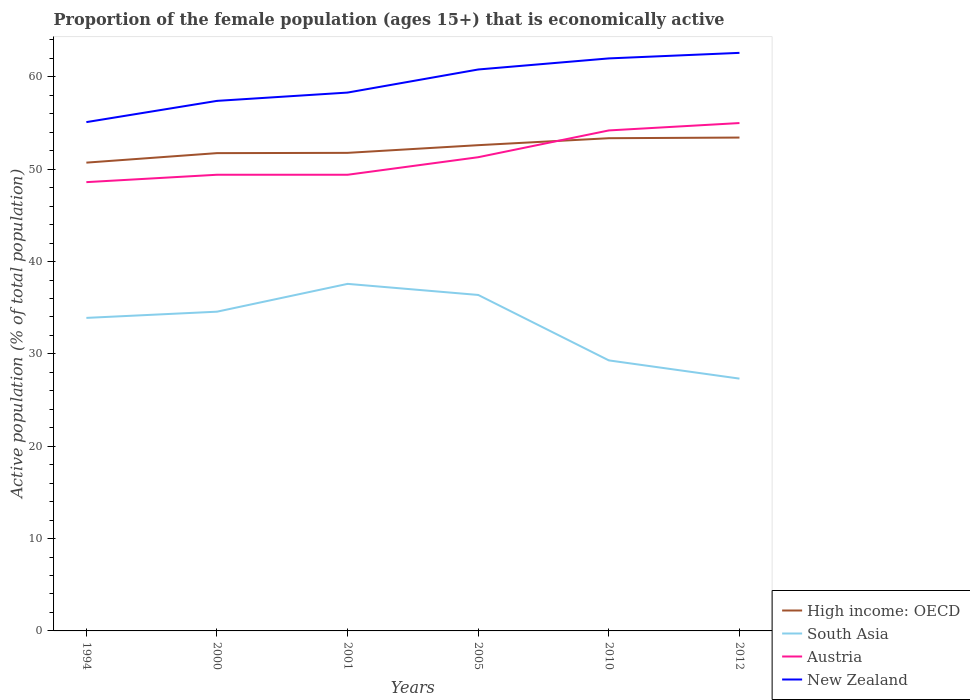Is the number of lines equal to the number of legend labels?
Offer a very short reply. Yes. Across all years, what is the maximum proportion of the female population that is economically active in South Asia?
Your answer should be very brief. 27.32. In which year was the proportion of the female population that is economically active in Austria maximum?
Keep it short and to the point. 1994. What is the total proportion of the female population that is economically active in New Zealand in the graph?
Offer a very short reply. -2.5. What is the difference between the highest and the second highest proportion of the female population that is economically active in South Asia?
Offer a terse response. 10.26. What is the difference between the highest and the lowest proportion of the female population that is economically active in Austria?
Provide a succinct answer. 2. Is the proportion of the female population that is economically active in High income: OECD strictly greater than the proportion of the female population that is economically active in South Asia over the years?
Offer a very short reply. No. How many lines are there?
Make the answer very short. 4. How many years are there in the graph?
Keep it short and to the point. 6. Are the values on the major ticks of Y-axis written in scientific E-notation?
Make the answer very short. No. Does the graph contain grids?
Offer a very short reply. No. How are the legend labels stacked?
Offer a very short reply. Vertical. What is the title of the graph?
Your response must be concise. Proportion of the female population (ages 15+) that is economically active. Does "Ukraine" appear as one of the legend labels in the graph?
Give a very brief answer. No. What is the label or title of the Y-axis?
Give a very brief answer. Active population (% of total population). What is the Active population (% of total population) of High income: OECD in 1994?
Give a very brief answer. 50.71. What is the Active population (% of total population) of South Asia in 1994?
Your response must be concise. 33.9. What is the Active population (% of total population) in Austria in 1994?
Make the answer very short. 48.6. What is the Active population (% of total population) of New Zealand in 1994?
Make the answer very short. 55.1. What is the Active population (% of total population) in High income: OECD in 2000?
Provide a succinct answer. 51.74. What is the Active population (% of total population) of South Asia in 2000?
Ensure brevity in your answer.  34.57. What is the Active population (% of total population) in Austria in 2000?
Give a very brief answer. 49.4. What is the Active population (% of total population) of New Zealand in 2000?
Give a very brief answer. 57.4. What is the Active population (% of total population) in High income: OECD in 2001?
Ensure brevity in your answer.  51.77. What is the Active population (% of total population) of South Asia in 2001?
Your answer should be compact. 37.58. What is the Active population (% of total population) of Austria in 2001?
Your response must be concise. 49.4. What is the Active population (% of total population) of New Zealand in 2001?
Your answer should be very brief. 58.3. What is the Active population (% of total population) in High income: OECD in 2005?
Your response must be concise. 52.6. What is the Active population (% of total population) in South Asia in 2005?
Provide a short and direct response. 36.38. What is the Active population (% of total population) of Austria in 2005?
Offer a very short reply. 51.3. What is the Active population (% of total population) in New Zealand in 2005?
Provide a short and direct response. 60.8. What is the Active population (% of total population) of High income: OECD in 2010?
Keep it short and to the point. 53.36. What is the Active population (% of total population) in South Asia in 2010?
Ensure brevity in your answer.  29.3. What is the Active population (% of total population) of Austria in 2010?
Your response must be concise. 54.2. What is the Active population (% of total population) of New Zealand in 2010?
Ensure brevity in your answer.  62. What is the Active population (% of total population) in High income: OECD in 2012?
Give a very brief answer. 53.43. What is the Active population (% of total population) in South Asia in 2012?
Make the answer very short. 27.32. What is the Active population (% of total population) of Austria in 2012?
Offer a very short reply. 55. What is the Active population (% of total population) in New Zealand in 2012?
Your answer should be compact. 62.6. Across all years, what is the maximum Active population (% of total population) of High income: OECD?
Give a very brief answer. 53.43. Across all years, what is the maximum Active population (% of total population) in South Asia?
Offer a terse response. 37.58. Across all years, what is the maximum Active population (% of total population) of New Zealand?
Offer a terse response. 62.6. Across all years, what is the minimum Active population (% of total population) of High income: OECD?
Provide a succinct answer. 50.71. Across all years, what is the minimum Active population (% of total population) in South Asia?
Offer a very short reply. 27.32. Across all years, what is the minimum Active population (% of total population) of Austria?
Offer a terse response. 48.6. Across all years, what is the minimum Active population (% of total population) in New Zealand?
Give a very brief answer. 55.1. What is the total Active population (% of total population) in High income: OECD in the graph?
Offer a terse response. 313.62. What is the total Active population (% of total population) of South Asia in the graph?
Give a very brief answer. 199.06. What is the total Active population (% of total population) of Austria in the graph?
Your response must be concise. 307.9. What is the total Active population (% of total population) in New Zealand in the graph?
Give a very brief answer. 356.2. What is the difference between the Active population (% of total population) of High income: OECD in 1994 and that in 2000?
Make the answer very short. -1.03. What is the difference between the Active population (% of total population) in South Asia in 1994 and that in 2000?
Give a very brief answer. -0.67. What is the difference between the Active population (% of total population) of High income: OECD in 1994 and that in 2001?
Make the answer very short. -1.06. What is the difference between the Active population (% of total population) of South Asia in 1994 and that in 2001?
Your response must be concise. -3.68. What is the difference between the Active population (% of total population) of High income: OECD in 1994 and that in 2005?
Provide a short and direct response. -1.89. What is the difference between the Active population (% of total population) in South Asia in 1994 and that in 2005?
Provide a succinct answer. -2.48. What is the difference between the Active population (% of total population) of Austria in 1994 and that in 2005?
Make the answer very short. -2.7. What is the difference between the Active population (% of total population) in New Zealand in 1994 and that in 2005?
Make the answer very short. -5.7. What is the difference between the Active population (% of total population) of High income: OECD in 1994 and that in 2010?
Provide a succinct answer. -2.65. What is the difference between the Active population (% of total population) of South Asia in 1994 and that in 2010?
Provide a short and direct response. 4.6. What is the difference between the Active population (% of total population) in High income: OECD in 1994 and that in 2012?
Offer a very short reply. -2.71. What is the difference between the Active population (% of total population) of South Asia in 1994 and that in 2012?
Offer a very short reply. 6.58. What is the difference between the Active population (% of total population) in New Zealand in 1994 and that in 2012?
Make the answer very short. -7.5. What is the difference between the Active population (% of total population) in High income: OECD in 2000 and that in 2001?
Provide a succinct answer. -0.03. What is the difference between the Active population (% of total population) in South Asia in 2000 and that in 2001?
Provide a succinct answer. -3.01. What is the difference between the Active population (% of total population) in Austria in 2000 and that in 2001?
Your response must be concise. 0. What is the difference between the Active population (% of total population) in High income: OECD in 2000 and that in 2005?
Offer a terse response. -0.86. What is the difference between the Active population (% of total population) in South Asia in 2000 and that in 2005?
Your response must be concise. -1.81. What is the difference between the Active population (% of total population) of New Zealand in 2000 and that in 2005?
Your response must be concise. -3.4. What is the difference between the Active population (% of total population) in High income: OECD in 2000 and that in 2010?
Ensure brevity in your answer.  -1.62. What is the difference between the Active population (% of total population) in South Asia in 2000 and that in 2010?
Ensure brevity in your answer.  5.27. What is the difference between the Active population (% of total population) of Austria in 2000 and that in 2010?
Provide a short and direct response. -4.8. What is the difference between the Active population (% of total population) in High income: OECD in 2000 and that in 2012?
Your response must be concise. -1.68. What is the difference between the Active population (% of total population) in South Asia in 2000 and that in 2012?
Make the answer very short. 7.25. What is the difference between the Active population (% of total population) of New Zealand in 2000 and that in 2012?
Make the answer very short. -5.2. What is the difference between the Active population (% of total population) in High income: OECD in 2001 and that in 2005?
Your answer should be compact. -0.83. What is the difference between the Active population (% of total population) in South Asia in 2001 and that in 2005?
Provide a succinct answer. 1.2. What is the difference between the Active population (% of total population) in Austria in 2001 and that in 2005?
Keep it short and to the point. -1.9. What is the difference between the Active population (% of total population) in New Zealand in 2001 and that in 2005?
Make the answer very short. -2.5. What is the difference between the Active population (% of total population) in High income: OECD in 2001 and that in 2010?
Your answer should be compact. -1.59. What is the difference between the Active population (% of total population) of South Asia in 2001 and that in 2010?
Your response must be concise. 8.29. What is the difference between the Active population (% of total population) of Austria in 2001 and that in 2010?
Your response must be concise. -4.8. What is the difference between the Active population (% of total population) in New Zealand in 2001 and that in 2010?
Offer a terse response. -3.7. What is the difference between the Active population (% of total population) of High income: OECD in 2001 and that in 2012?
Offer a terse response. -1.66. What is the difference between the Active population (% of total population) in South Asia in 2001 and that in 2012?
Provide a short and direct response. 10.26. What is the difference between the Active population (% of total population) in Austria in 2001 and that in 2012?
Give a very brief answer. -5.6. What is the difference between the Active population (% of total population) in High income: OECD in 2005 and that in 2010?
Ensure brevity in your answer.  -0.76. What is the difference between the Active population (% of total population) in South Asia in 2005 and that in 2010?
Offer a very short reply. 7.09. What is the difference between the Active population (% of total population) of New Zealand in 2005 and that in 2010?
Ensure brevity in your answer.  -1.2. What is the difference between the Active population (% of total population) in High income: OECD in 2005 and that in 2012?
Make the answer very short. -0.82. What is the difference between the Active population (% of total population) of South Asia in 2005 and that in 2012?
Offer a very short reply. 9.06. What is the difference between the Active population (% of total population) in Austria in 2005 and that in 2012?
Give a very brief answer. -3.7. What is the difference between the Active population (% of total population) of High income: OECD in 2010 and that in 2012?
Provide a succinct answer. -0.07. What is the difference between the Active population (% of total population) in South Asia in 2010 and that in 2012?
Offer a very short reply. 1.97. What is the difference between the Active population (% of total population) of High income: OECD in 1994 and the Active population (% of total population) of South Asia in 2000?
Your answer should be compact. 16.14. What is the difference between the Active population (% of total population) of High income: OECD in 1994 and the Active population (% of total population) of Austria in 2000?
Ensure brevity in your answer.  1.31. What is the difference between the Active population (% of total population) of High income: OECD in 1994 and the Active population (% of total population) of New Zealand in 2000?
Make the answer very short. -6.69. What is the difference between the Active population (% of total population) of South Asia in 1994 and the Active population (% of total population) of Austria in 2000?
Offer a very short reply. -15.5. What is the difference between the Active population (% of total population) in South Asia in 1994 and the Active population (% of total population) in New Zealand in 2000?
Offer a very short reply. -23.5. What is the difference between the Active population (% of total population) in Austria in 1994 and the Active population (% of total population) in New Zealand in 2000?
Give a very brief answer. -8.8. What is the difference between the Active population (% of total population) of High income: OECD in 1994 and the Active population (% of total population) of South Asia in 2001?
Your answer should be compact. 13.13. What is the difference between the Active population (% of total population) in High income: OECD in 1994 and the Active population (% of total population) in Austria in 2001?
Provide a short and direct response. 1.31. What is the difference between the Active population (% of total population) of High income: OECD in 1994 and the Active population (% of total population) of New Zealand in 2001?
Make the answer very short. -7.59. What is the difference between the Active population (% of total population) in South Asia in 1994 and the Active population (% of total population) in Austria in 2001?
Offer a very short reply. -15.5. What is the difference between the Active population (% of total population) of South Asia in 1994 and the Active population (% of total population) of New Zealand in 2001?
Provide a short and direct response. -24.4. What is the difference between the Active population (% of total population) in Austria in 1994 and the Active population (% of total population) in New Zealand in 2001?
Your answer should be compact. -9.7. What is the difference between the Active population (% of total population) in High income: OECD in 1994 and the Active population (% of total population) in South Asia in 2005?
Provide a succinct answer. 14.33. What is the difference between the Active population (% of total population) of High income: OECD in 1994 and the Active population (% of total population) of Austria in 2005?
Keep it short and to the point. -0.59. What is the difference between the Active population (% of total population) in High income: OECD in 1994 and the Active population (% of total population) in New Zealand in 2005?
Give a very brief answer. -10.09. What is the difference between the Active population (% of total population) of South Asia in 1994 and the Active population (% of total population) of Austria in 2005?
Offer a very short reply. -17.4. What is the difference between the Active population (% of total population) of South Asia in 1994 and the Active population (% of total population) of New Zealand in 2005?
Provide a short and direct response. -26.9. What is the difference between the Active population (% of total population) in High income: OECD in 1994 and the Active population (% of total population) in South Asia in 2010?
Provide a succinct answer. 21.42. What is the difference between the Active population (% of total population) in High income: OECD in 1994 and the Active population (% of total population) in Austria in 2010?
Give a very brief answer. -3.49. What is the difference between the Active population (% of total population) in High income: OECD in 1994 and the Active population (% of total population) in New Zealand in 2010?
Ensure brevity in your answer.  -11.29. What is the difference between the Active population (% of total population) in South Asia in 1994 and the Active population (% of total population) in Austria in 2010?
Provide a succinct answer. -20.3. What is the difference between the Active population (% of total population) in South Asia in 1994 and the Active population (% of total population) in New Zealand in 2010?
Offer a terse response. -28.1. What is the difference between the Active population (% of total population) in High income: OECD in 1994 and the Active population (% of total population) in South Asia in 2012?
Give a very brief answer. 23.39. What is the difference between the Active population (% of total population) of High income: OECD in 1994 and the Active population (% of total population) of Austria in 2012?
Your response must be concise. -4.29. What is the difference between the Active population (% of total population) in High income: OECD in 1994 and the Active population (% of total population) in New Zealand in 2012?
Your response must be concise. -11.89. What is the difference between the Active population (% of total population) of South Asia in 1994 and the Active population (% of total population) of Austria in 2012?
Keep it short and to the point. -21.1. What is the difference between the Active population (% of total population) of South Asia in 1994 and the Active population (% of total population) of New Zealand in 2012?
Ensure brevity in your answer.  -28.7. What is the difference between the Active population (% of total population) in Austria in 1994 and the Active population (% of total population) in New Zealand in 2012?
Offer a very short reply. -14. What is the difference between the Active population (% of total population) in High income: OECD in 2000 and the Active population (% of total population) in South Asia in 2001?
Offer a very short reply. 14.16. What is the difference between the Active population (% of total population) of High income: OECD in 2000 and the Active population (% of total population) of Austria in 2001?
Your answer should be very brief. 2.34. What is the difference between the Active population (% of total population) of High income: OECD in 2000 and the Active population (% of total population) of New Zealand in 2001?
Offer a very short reply. -6.56. What is the difference between the Active population (% of total population) of South Asia in 2000 and the Active population (% of total population) of Austria in 2001?
Your response must be concise. -14.83. What is the difference between the Active population (% of total population) in South Asia in 2000 and the Active population (% of total population) in New Zealand in 2001?
Your response must be concise. -23.73. What is the difference between the Active population (% of total population) in Austria in 2000 and the Active population (% of total population) in New Zealand in 2001?
Make the answer very short. -8.9. What is the difference between the Active population (% of total population) in High income: OECD in 2000 and the Active population (% of total population) in South Asia in 2005?
Provide a short and direct response. 15.36. What is the difference between the Active population (% of total population) of High income: OECD in 2000 and the Active population (% of total population) of Austria in 2005?
Your response must be concise. 0.44. What is the difference between the Active population (% of total population) of High income: OECD in 2000 and the Active population (% of total population) of New Zealand in 2005?
Keep it short and to the point. -9.06. What is the difference between the Active population (% of total population) in South Asia in 2000 and the Active population (% of total population) in Austria in 2005?
Your answer should be very brief. -16.73. What is the difference between the Active population (% of total population) in South Asia in 2000 and the Active population (% of total population) in New Zealand in 2005?
Offer a terse response. -26.23. What is the difference between the Active population (% of total population) of Austria in 2000 and the Active population (% of total population) of New Zealand in 2005?
Ensure brevity in your answer.  -11.4. What is the difference between the Active population (% of total population) in High income: OECD in 2000 and the Active population (% of total population) in South Asia in 2010?
Your answer should be compact. 22.45. What is the difference between the Active population (% of total population) in High income: OECD in 2000 and the Active population (% of total population) in Austria in 2010?
Provide a succinct answer. -2.46. What is the difference between the Active population (% of total population) in High income: OECD in 2000 and the Active population (% of total population) in New Zealand in 2010?
Your response must be concise. -10.26. What is the difference between the Active population (% of total population) of South Asia in 2000 and the Active population (% of total population) of Austria in 2010?
Your answer should be compact. -19.63. What is the difference between the Active population (% of total population) in South Asia in 2000 and the Active population (% of total population) in New Zealand in 2010?
Offer a very short reply. -27.43. What is the difference between the Active population (% of total population) of High income: OECD in 2000 and the Active population (% of total population) of South Asia in 2012?
Provide a succinct answer. 24.42. What is the difference between the Active population (% of total population) in High income: OECD in 2000 and the Active population (% of total population) in Austria in 2012?
Ensure brevity in your answer.  -3.26. What is the difference between the Active population (% of total population) of High income: OECD in 2000 and the Active population (% of total population) of New Zealand in 2012?
Your response must be concise. -10.86. What is the difference between the Active population (% of total population) in South Asia in 2000 and the Active population (% of total population) in Austria in 2012?
Your response must be concise. -20.43. What is the difference between the Active population (% of total population) in South Asia in 2000 and the Active population (% of total population) in New Zealand in 2012?
Give a very brief answer. -28.03. What is the difference between the Active population (% of total population) in Austria in 2000 and the Active population (% of total population) in New Zealand in 2012?
Your answer should be compact. -13.2. What is the difference between the Active population (% of total population) in High income: OECD in 2001 and the Active population (% of total population) in South Asia in 2005?
Provide a short and direct response. 15.39. What is the difference between the Active population (% of total population) of High income: OECD in 2001 and the Active population (% of total population) of Austria in 2005?
Provide a succinct answer. 0.47. What is the difference between the Active population (% of total population) of High income: OECD in 2001 and the Active population (% of total population) of New Zealand in 2005?
Provide a short and direct response. -9.03. What is the difference between the Active population (% of total population) of South Asia in 2001 and the Active population (% of total population) of Austria in 2005?
Keep it short and to the point. -13.72. What is the difference between the Active population (% of total population) in South Asia in 2001 and the Active population (% of total population) in New Zealand in 2005?
Provide a short and direct response. -23.22. What is the difference between the Active population (% of total population) of High income: OECD in 2001 and the Active population (% of total population) of South Asia in 2010?
Give a very brief answer. 22.48. What is the difference between the Active population (% of total population) of High income: OECD in 2001 and the Active population (% of total population) of Austria in 2010?
Offer a very short reply. -2.43. What is the difference between the Active population (% of total population) of High income: OECD in 2001 and the Active population (% of total population) of New Zealand in 2010?
Give a very brief answer. -10.23. What is the difference between the Active population (% of total population) in South Asia in 2001 and the Active population (% of total population) in Austria in 2010?
Your answer should be compact. -16.62. What is the difference between the Active population (% of total population) in South Asia in 2001 and the Active population (% of total population) in New Zealand in 2010?
Keep it short and to the point. -24.42. What is the difference between the Active population (% of total population) in Austria in 2001 and the Active population (% of total population) in New Zealand in 2010?
Your answer should be compact. -12.6. What is the difference between the Active population (% of total population) of High income: OECD in 2001 and the Active population (% of total population) of South Asia in 2012?
Offer a terse response. 24.45. What is the difference between the Active population (% of total population) in High income: OECD in 2001 and the Active population (% of total population) in Austria in 2012?
Give a very brief answer. -3.23. What is the difference between the Active population (% of total population) in High income: OECD in 2001 and the Active population (% of total population) in New Zealand in 2012?
Offer a terse response. -10.83. What is the difference between the Active population (% of total population) in South Asia in 2001 and the Active population (% of total population) in Austria in 2012?
Keep it short and to the point. -17.42. What is the difference between the Active population (% of total population) in South Asia in 2001 and the Active population (% of total population) in New Zealand in 2012?
Provide a short and direct response. -25.02. What is the difference between the Active population (% of total population) in High income: OECD in 2005 and the Active population (% of total population) in South Asia in 2010?
Make the answer very short. 23.31. What is the difference between the Active population (% of total population) of High income: OECD in 2005 and the Active population (% of total population) of Austria in 2010?
Make the answer very short. -1.6. What is the difference between the Active population (% of total population) of High income: OECD in 2005 and the Active population (% of total population) of New Zealand in 2010?
Your answer should be very brief. -9.4. What is the difference between the Active population (% of total population) of South Asia in 2005 and the Active population (% of total population) of Austria in 2010?
Your answer should be compact. -17.82. What is the difference between the Active population (% of total population) in South Asia in 2005 and the Active population (% of total population) in New Zealand in 2010?
Provide a short and direct response. -25.62. What is the difference between the Active population (% of total population) of High income: OECD in 2005 and the Active population (% of total population) of South Asia in 2012?
Your answer should be very brief. 25.28. What is the difference between the Active population (% of total population) in High income: OECD in 2005 and the Active population (% of total population) in Austria in 2012?
Give a very brief answer. -2.4. What is the difference between the Active population (% of total population) in High income: OECD in 2005 and the Active population (% of total population) in New Zealand in 2012?
Ensure brevity in your answer.  -10. What is the difference between the Active population (% of total population) in South Asia in 2005 and the Active population (% of total population) in Austria in 2012?
Offer a terse response. -18.62. What is the difference between the Active population (% of total population) in South Asia in 2005 and the Active population (% of total population) in New Zealand in 2012?
Make the answer very short. -26.22. What is the difference between the Active population (% of total population) of Austria in 2005 and the Active population (% of total population) of New Zealand in 2012?
Offer a terse response. -11.3. What is the difference between the Active population (% of total population) of High income: OECD in 2010 and the Active population (% of total population) of South Asia in 2012?
Ensure brevity in your answer.  26.04. What is the difference between the Active population (% of total population) in High income: OECD in 2010 and the Active population (% of total population) in Austria in 2012?
Offer a terse response. -1.64. What is the difference between the Active population (% of total population) of High income: OECD in 2010 and the Active population (% of total population) of New Zealand in 2012?
Offer a very short reply. -9.24. What is the difference between the Active population (% of total population) of South Asia in 2010 and the Active population (% of total population) of Austria in 2012?
Give a very brief answer. -25.7. What is the difference between the Active population (% of total population) of South Asia in 2010 and the Active population (% of total population) of New Zealand in 2012?
Your response must be concise. -33.3. What is the difference between the Active population (% of total population) in Austria in 2010 and the Active population (% of total population) in New Zealand in 2012?
Make the answer very short. -8.4. What is the average Active population (% of total population) in High income: OECD per year?
Keep it short and to the point. 52.27. What is the average Active population (% of total population) in South Asia per year?
Provide a short and direct response. 33.18. What is the average Active population (% of total population) of Austria per year?
Offer a very short reply. 51.32. What is the average Active population (% of total population) of New Zealand per year?
Offer a very short reply. 59.37. In the year 1994, what is the difference between the Active population (% of total population) in High income: OECD and Active population (% of total population) in South Asia?
Offer a terse response. 16.81. In the year 1994, what is the difference between the Active population (% of total population) of High income: OECD and Active population (% of total population) of Austria?
Ensure brevity in your answer.  2.11. In the year 1994, what is the difference between the Active population (% of total population) in High income: OECD and Active population (% of total population) in New Zealand?
Give a very brief answer. -4.39. In the year 1994, what is the difference between the Active population (% of total population) of South Asia and Active population (% of total population) of Austria?
Provide a short and direct response. -14.7. In the year 1994, what is the difference between the Active population (% of total population) in South Asia and Active population (% of total population) in New Zealand?
Offer a very short reply. -21.2. In the year 1994, what is the difference between the Active population (% of total population) of Austria and Active population (% of total population) of New Zealand?
Offer a terse response. -6.5. In the year 2000, what is the difference between the Active population (% of total population) of High income: OECD and Active population (% of total population) of South Asia?
Offer a very short reply. 17.17. In the year 2000, what is the difference between the Active population (% of total population) of High income: OECD and Active population (% of total population) of Austria?
Make the answer very short. 2.34. In the year 2000, what is the difference between the Active population (% of total population) in High income: OECD and Active population (% of total population) in New Zealand?
Ensure brevity in your answer.  -5.66. In the year 2000, what is the difference between the Active population (% of total population) in South Asia and Active population (% of total population) in Austria?
Provide a short and direct response. -14.83. In the year 2000, what is the difference between the Active population (% of total population) in South Asia and Active population (% of total population) in New Zealand?
Keep it short and to the point. -22.83. In the year 2001, what is the difference between the Active population (% of total population) in High income: OECD and Active population (% of total population) in South Asia?
Your answer should be very brief. 14.19. In the year 2001, what is the difference between the Active population (% of total population) of High income: OECD and Active population (% of total population) of Austria?
Your answer should be compact. 2.37. In the year 2001, what is the difference between the Active population (% of total population) in High income: OECD and Active population (% of total population) in New Zealand?
Offer a terse response. -6.53. In the year 2001, what is the difference between the Active population (% of total population) of South Asia and Active population (% of total population) of Austria?
Ensure brevity in your answer.  -11.82. In the year 2001, what is the difference between the Active population (% of total population) in South Asia and Active population (% of total population) in New Zealand?
Your answer should be very brief. -20.72. In the year 2001, what is the difference between the Active population (% of total population) of Austria and Active population (% of total population) of New Zealand?
Provide a short and direct response. -8.9. In the year 2005, what is the difference between the Active population (% of total population) in High income: OECD and Active population (% of total population) in South Asia?
Provide a succinct answer. 16.22. In the year 2005, what is the difference between the Active population (% of total population) in High income: OECD and Active population (% of total population) in Austria?
Your answer should be compact. 1.3. In the year 2005, what is the difference between the Active population (% of total population) of High income: OECD and Active population (% of total population) of New Zealand?
Ensure brevity in your answer.  -8.2. In the year 2005, what is the difference between the Active population (% of total population) of South Asia and Active population (% of total population) of Austria?
Your answer should be very brief. -14.92. In the year 2005, what is the difference between the Active population (% of total population) of South Asia and Active population (% of total population) of New Zealand?
Your answer should be compact. -24.42. In the year 2005, what is the difference between the Active population (% of total population) in Austria and Active population (% of total population) in New Zealand?
Your answer should be very brief. -9.5. In the year 2010, what is the difference between the Active population (% of total population) of High income: OECD and Active population (% of total population) of South Asia?
Give a very brief answer. 24.06. In the year 2010, what is the difference between the Active population (% of total population) of High income: OECD and Active population (% of total population) of Austria?
Offer a terse response. -0.84. In the year 2010, what is the difference between the Active population (% of total population) of High income: OECD and Active population (% of total population) of New Zealand?
Give a very brief answer. -8.64. In the year 2010, what is the difference between the Active population (% of total population) in South Asia and Active population (% of total population) in Austria?
Your answer should be very brief. -24.9. In the year 2010, what is the difference between the Active population (% of total population) of South Asia and Active population (% of total population) of New Zealand?
Offer a terse response. -32.7. In the year 2012, what is the difference between the Active population (% of total population) of High income: OECD and Active population (% of total population) of South Asia?
Give a very brief answer. 26.1. In the year 2012, what is the difference between the Active population (% of total population) in High income: OECD and Active population (% of total population) in Austria?
Make the answer very short. -1.57. In the year 2012, what is the difference between the Active population (% of total population) of High income: OECD and Active population (% of total population) of New Zealand?
Provide a succinct answer. -9.17. In the year 2012, what is the difference between the Active population (% of total population) of South Asia and Active population (% of total population) of Austria?
Keep it short and to the point. -27.68. In the year 2012, what is the difference between the Active population (% of total population) in South Asia and Active population (% of total population) in New Zealand?
Provide a short and direct response. -35.28. In the year 2012, what is the difference between the Active population (% of total population) in Austria and Active population (% of total population) in New Zealand?
Your answer should be compact. -7.6. What is the ratio of the Active population (% of total population) in High income: OECD in 1994 to that in 2000?
Provide a succinct answer. 0.98. What is the ratio of the Active population (% of total population) of South Asia in 1994 to that in 2000?
Offer a very short reply. 0.98. What is the ratio of the Active population (% of total population) in Austria in 1994 to that in 2000?
Your answer should be compact. 0.98. What is the ratio of the Active population (% of total population) of New Zealand in 1994 to that in 2000?
Your answer should be very brief. 0.96. What is the ratio of the Active population (% of total population) of High income: OECD in 1994 to that in 2001?
Provide a short and direct response. 0.98. What is the ratio of the Active population (% of total population) of South Asia in 1994 to that in 2001?
Offer a very short reply. 0.9. What is the ratio of the Active population (% of total population) of Austria in 1994 to that in 2001?
Your response must be concise. 0.98. What is the ratio of the Active population (% of total population) of New Zealand in 1994 to that in 2001?
Provide a short and direct response. 0.95. What is the ratio of the Active population (% of total population) in High income: OECD in 1994 to that in 2005?
Make the answer very short. 0.96. What is the ratio of the Active population (% of total population) in South Asia in 1994 to that in 2005?
Keep it short and to the point. 0.93. What is the ratio of the Active population (% of total population) of New Zealand in 1994 to that in 2005?
Your answer should be very brief. 0.91. What is the ratio of the Active population (% of total population) in High income: OECD in 1994 to that in 2010?
Offer a terse response. 0.95. What is the ratio of the Active population (% of total population) of South Asia in 1994 to that in 2010?
Your response must be concise. 1.16. What is the ratio of the Active population (% of total population) in Austria in 1994 to that in 2010?
Keep it short and to the point. 0.9. What is the ratio of the Active population (% of total population) in New Zealand in 1994 to that in 2010?
Keep it short and to the point. 0.89. What is the ratio of the Active population (% of total population) in High income: OECD in 1994 to that in 2012?
Your response must be concise. 0.95. What is the ratio of the Active population (% of total population) in South Asia in 1994 to that in 2012?
Provide a short and direct response. 1.24. What is the ratio of the Active population (% of total population) of Austria in 1994 to that in 2012?
Give a very brief answer. 0.88. What is the ratio of the Active population (% of total population) in New Zealand in 1994 to that in 2012?
Your response must be concise. 0.88. What is the ratio of the Active population (% of total population) in High income: OECD in 2000 to that in 2001?
Give a very brief answer. 1. What is the ratio of the Active population (% of total population) in South Asia in 2000 to that in 2001?
Your answer should be compact. 0.92. What is the ratio of the Active population (% of total population) of New Zealand in 2000 to that in 2001?
Offer a terse response. 0.98. What is the ratio of the Active population (% of total population) in High income: OECD in 2000 to that in 2005?
Offer a terse response. 0.98. What is the ratio of the Active population (% of total population) in South Asia in 2000 to that in 2005?
Offer a very short reply. 0.95. What is the ratio of the Active population (% of total population) in Austria in 2000 to that in 2005?
Provide a succinct answer. 0.96. What is the ratio of the Active population (% of total population) of New Zealand in 2000 to that in 2005?
Offer a terse response. 0.94. What is the ratio of the Active population (% of total population) in High income: OECD in 2000 to that in 2010?
Your answer should be very brief. 0.97. What is the ratio of the Active population (% of total population) of South Asia in 2000 to that in 2010?
Your answer should be very brief. 1.18. What is the ratio of the Active population (% of total population) of Austria in 2000 to that in 2010?
Provide a succinct answer. 0.91. What is the ratio of the Active population (% of total population) in New Zealand in 2000 to that in 2010?
Ensure brevity in your answer.  0.93. What is the ratio of the Active population (% of total population) of High income: OECD in 2000 to that in 2012?
Your answer should be compact. 0.97. What is the ratio of the Active population (% of total population) in South Asia in 2000 to that in 2012?
Your response must be concise. 1.27. What is the ratio of the Active population (% of total population) in Austria in 2000 to that in 2012?
Make the answer very short. 0.9. What is the ratio of the Active population (% of total population) in New Zealand in 2000 to that in 2012?
Your answer should be very brief. 0.92. What is the ratio of the Active population (% of total population) of High income: OECD in 2001 to that in 2005?
Ensure brevity in your answer.  0.98. What is the ratio of the Active population (% of total population) in South Asia in 2001 to that in 2005?
Your answer should be very brief. 1.03. What is the ratio of the Active population (% of total population) of New Zealand in 2001 to that in 2005?
Offer a terse response. 0.96. What is the ratio of the Active population (% of total population) of High income: OECD in 2001 to that in 2010?
Make the answer very short. 0.97. What is the ratio of the Active population (% of total population) of South Asia in 2001 to that in 2010?
Ensure brevity in your answer.  1.28. What is the ratio of the Active population (% of total population) in Austria in 2001 to that in 2010?
Make the answer very short. 0.91. What is the ratio of the Active population (% of total population) in New Zealand in 2001 to that in 2010?
Give a very brief answer. 0.94. What is the ratio of the Active population (% of total population) in South Asia in 2001 to that in 2012?
Your answer should be very brief. 1.38. What is the ratio of the Active population (% of total population) in Austria in 2001 to that in 2012?
Your answer should be very brief. 0.9. What is the ratio of the Active population (% of total population) of New Zealand in 2001 to that in 2012?
Make the answer very short. 0.93. What is the ratio of the Active population (% of total population) of High income: OECD in 2005 to that in 2010?
Ensure brevity in your answer.  0.99. What is the ratio of the Active population (% of total population) in South Asia in 2005 to that in 2010?
Your response must be concise. 1.24. What is the ratio of the Active population (% of total population) of Austria in 2005 to that in 2010?
Your response must be concise. 0.95. What is the ratio of the Active population (% of total population) in New Zealand in 2005 to that in 2010?
Your response must be concise. 0.98. What is the ratio of the Active population (% of total population) in High income: OECD in 2005 to that in 2012?
Make the answer very short. 0.98. What is the ratio of the Active population (% of total population) of South Asia in 2005 to that in 2012?
Give a very brief answer. 1.33. What is the ratio of the Active population (% of total population) of Austria in 2005 to that in 2012?
Your answer should be compact. 0.93. What is the ratio of the Active population (% of total population) in New Zealand in 2005 to that in 2012?
Offer a terse response. 0.97. What is the ratio of the Active population (% of total population) in High income: OECD in 2010 to that in 2012?
Make the answer very short. 1. What is the ratio of the Active population (% of total population) of South Asia in 2010 to that in 2012?
Ensure brevity in your answer.  1.07. What is the ratio of the Active population (% of total population) in Austria in 2010 to that in 2012?
Make the answer very short. 0.99. What is the difference between the highest and the second highest Active population (% of total population) in High income: OECD?
Provide a short and direct response. 0.07. What is the difference between the highest and the second highest Active population (% of total population) of South Asia?
Give a very brief answer. 1.2. What is the difference between the highest and the second highest Active population (% of total population) of Austria?
Offer a very short reply. 0.8. What is the difference between the highest and the lowest Active population (% of total population) in High income: OECD?
Your answer should be very brief. 2.71. What is the difference between the highest and the lowest Active population (% of total population) in South Asia?
Offer a terse response. 10.26. What is the difference between the highest and the lowest Active population (% of total population) in Austria?
Your answer should be very brief. 6.4. What is the difference between the highest and the lowest Active population (% of total population) in New Zealand?
Make the answer very short. 7.5. 